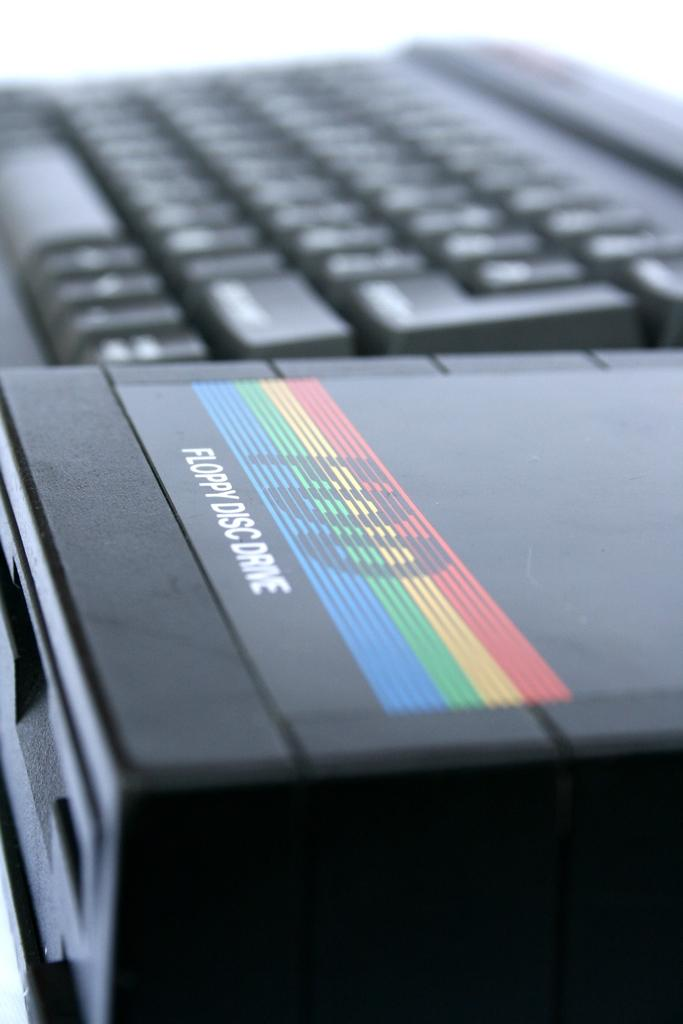<image>
Describe the image concisely. An FDD floppy disc drive sits next to a large black keyboard. 